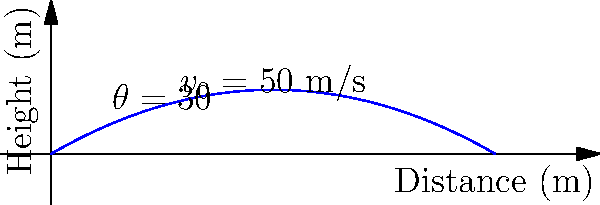Consider a projectile launched with an initial velocity of 50 m/s at an angle of 30° above the horizontal, as shown in the diagram. Neglecting air resistance, what concise phrase best describes the shape of the projectile's trajectory, and why is this shape universal for all projectiles under ideal conditions? To answer this question, let's break it down step-by-step:

1. The shape of the trajectory:
   The path traced by the projectile is a parabola. This can be seen from the blue curve in the diagram.

2. Why this shape is universal:
   a) The motion of the projectile can be separated into two components:
      - Horizontal motion: Constant velocity (no acceleration)
      - Vertical motion: Constant acceleration due to gravity

   b) The equations of motion for these components are:
      - Horizontal: $x = v_0 \cos(\theta) t$
      - Vertical: $y = v_0 \sin(\theta) t - \frac{1}{2}gt^2$

   c) Eliminating time $t$ from these equations gives us:
      $y = (x \tan(\theta)) - (\frac{g}{2v_0^2 \cos^2(\theta)})x^2$

   d) This equation is in the form $y = ax - bx^2$, which is the general equation of a parabola.

3. Universality:
   The parabolic shape is independent of the initial velocity and angle. These factors only affect the scale and orientation of the parabola, not its fundamental shape.

4. Ideal conditions:
   This shape holds true under ideal conditions (no air resistance, uniform gravitational field) because only gravity acts on the projectile, providing a constant downward acceleration.
Answer: Parabola; constant horizontal velocity and vertical acceleration. 